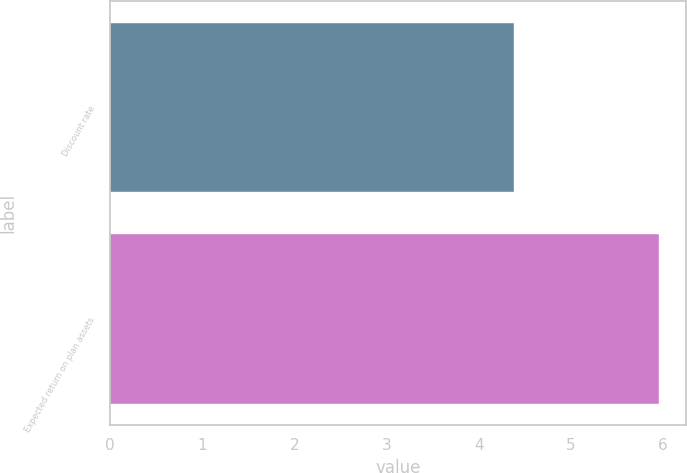<chart> <loc_0><loc_0><loc_500><loc_500><bar_chart><fcel>Discount rate<fcel>Expected return on plan assets<nl><fcel>4.38<fcel>5.95<nl></chart> 